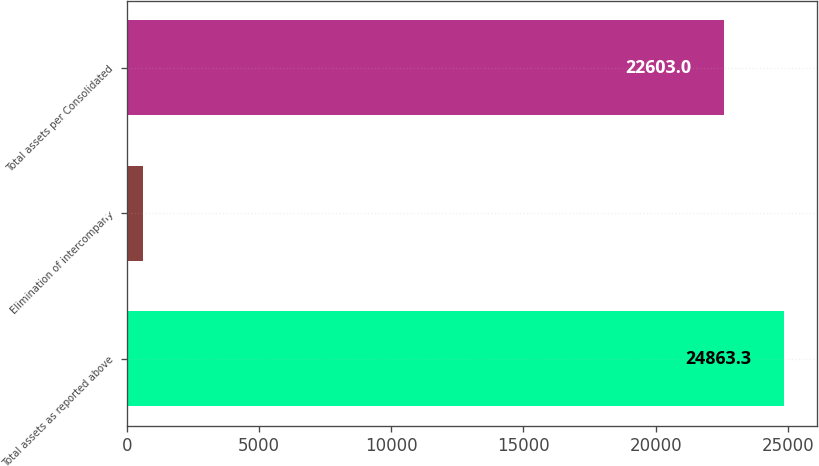Convert chart. <chart><loc_0><loc_0><loc_500><loc_500><bar_chart><fcel>Total assets as reported above<fcel>Elimination of intercompany<fcel>Total assets per Consolidated<nl><fcel>24863.3<fcel>612<fcel>22603<nl></chart> 